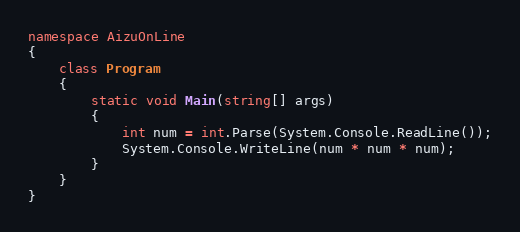Convert code to text. <code><loc_0><loc_0><loc_500><loc_500><_C#_>namespace AizuOnLine
{
    class Program
    {
        static void Main(string[] args)
        {
            int num = int.Parse(System.Console.ReadLine());
            System.Console.WriteLine(num * num * num);
        }
    }
}</code> 